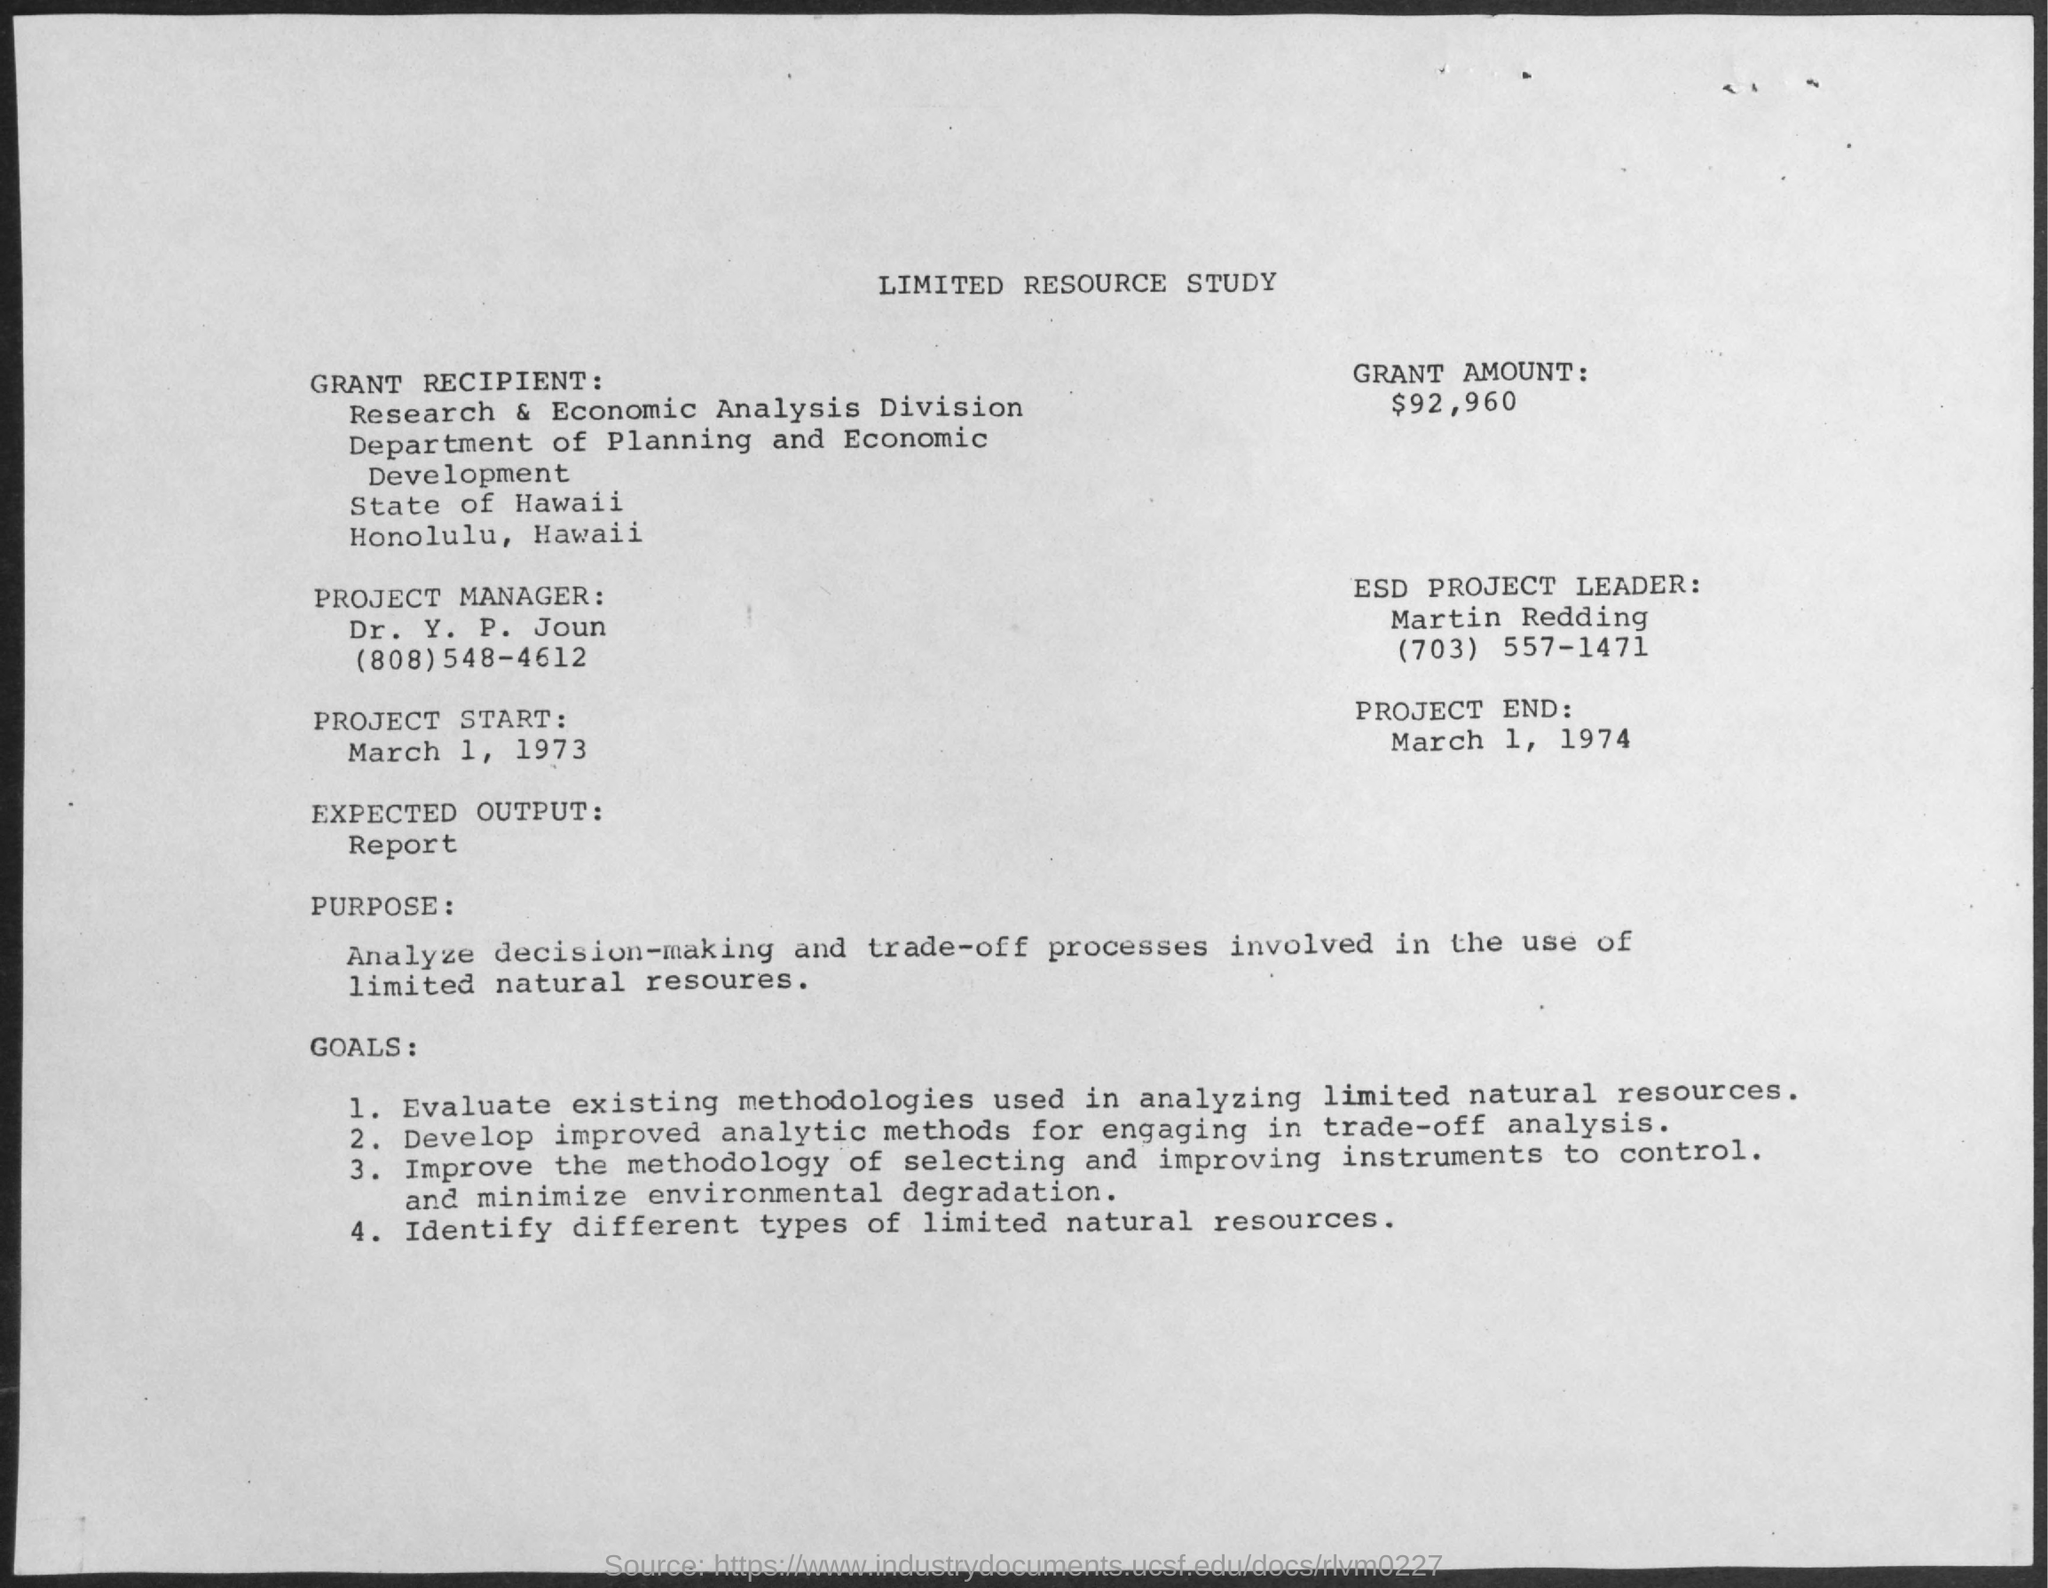What is the grant amount mentioned in the given resource study ?
Your response must be concise. $92,960. What is the date of the project start ?
Your answer should be compact. March 1, 1973. What is the name of the esd project leader ?
Your answer should be compact. Martin Redding. What is the date of project end ?
Your response must be concise. March 1, 1974. What is the expected output ?
Your answer should be compact. Report. What is the name of the grant recipient ?
Provide a succinct answer. Research & economic analysis division. What is the name of the department mentioned in the given resource study ?
Offer a very short reply. Department of Planning and Economic Development. 